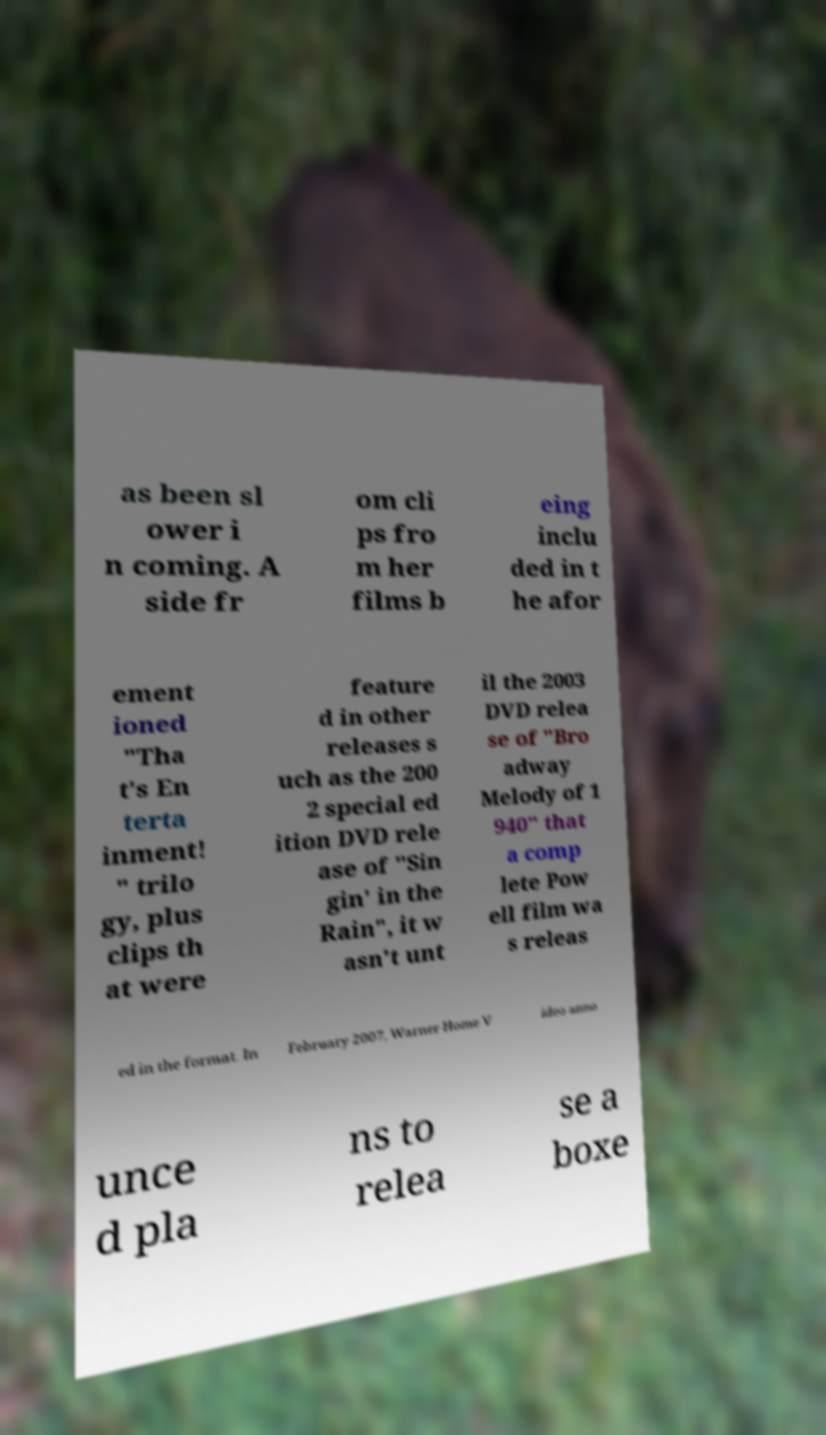Please read and relay the text visible in this image. What does it say? as been sl ower i n coming. A side fr om cli ps fro m her films b eing inclu ded in t he afor ement ioned "Tha t's En terta inment! " trilo gy, plus clips th at were feature d in other releases s uch as the 200 2 special ed ition DVD rele ase of "Sin gin' in the Rain", it w asn't unt il the 2003 DVD relea se of "Bro adway Melody of 1 940" that a comp lete Pow ell film wa s releas ed in the format. In February 2007, Warner Home V ideo anno unce d pla ns to relea se a boxe 